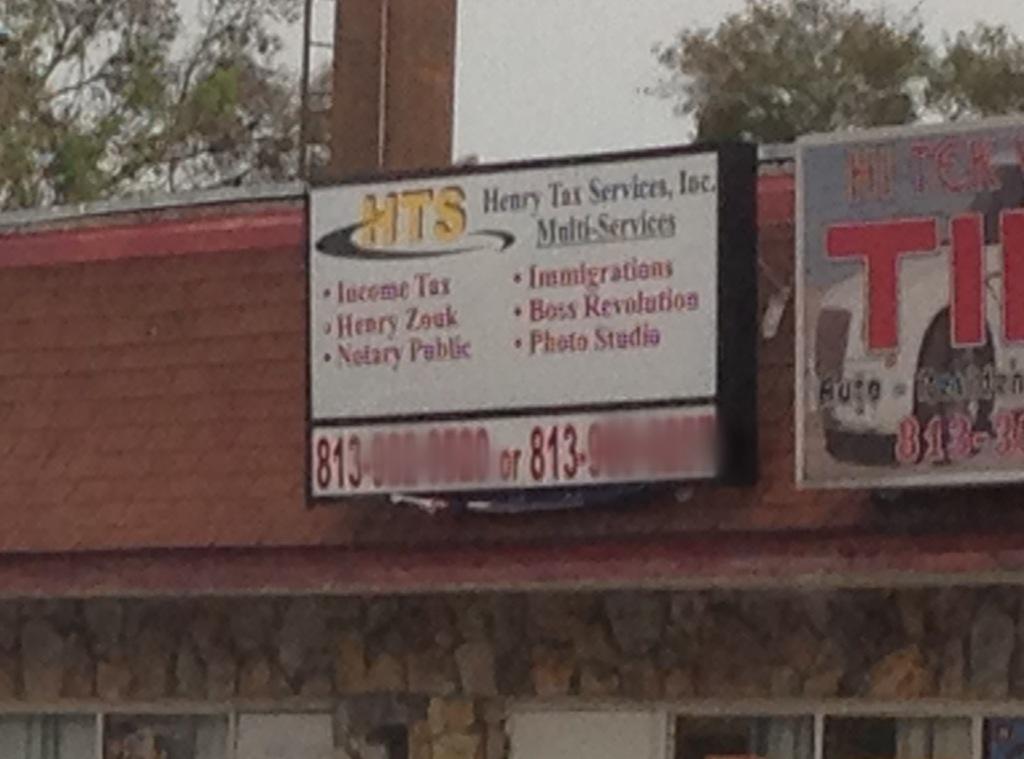What are the initials of this company?
Ensure brevity in your answer.  Hts. 